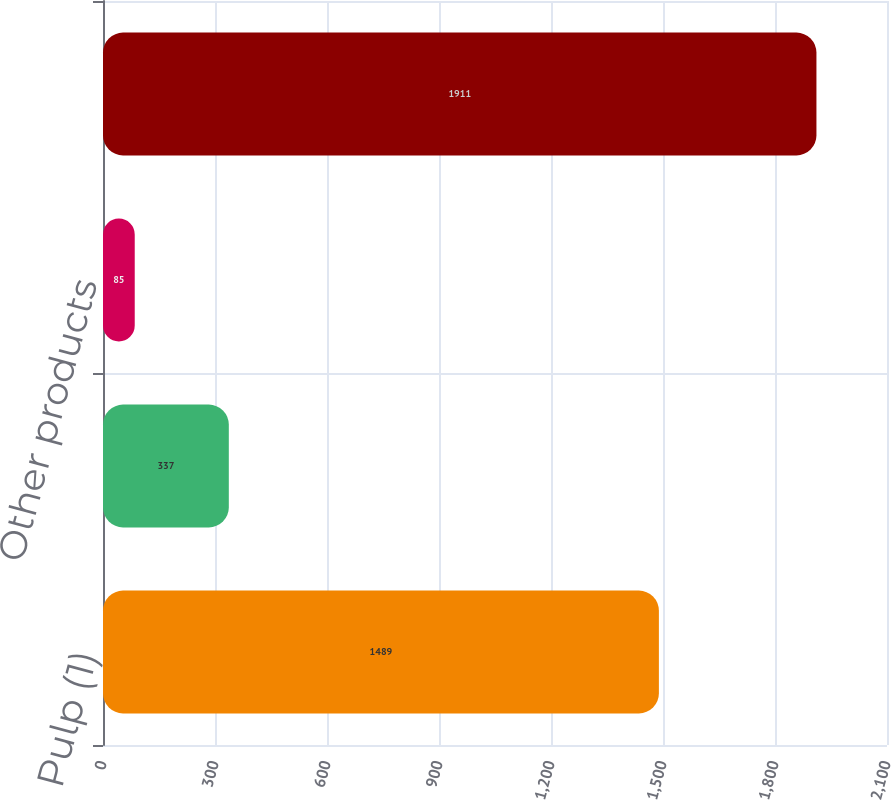Convert chart. <chart><loc_0><loc_0><loc_500><loc_500><bar_chart><fcel>Pulp (1)<fcel>Liquid packaging board<fcel>Other products<fcel>Total<nl><fcel>1489<fcel>337<fcel>85<fcel>1911<nl></chart> 